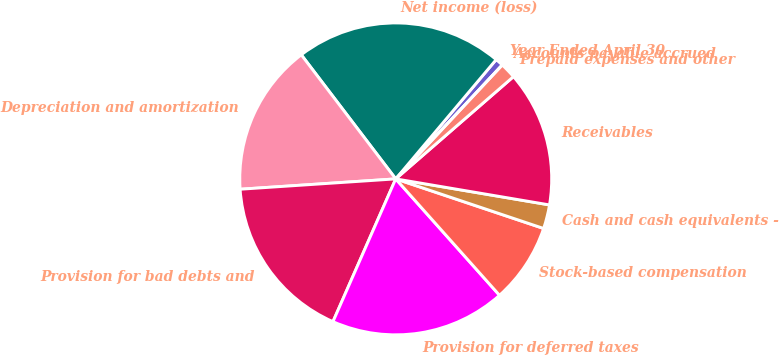Convert chart. <chart><loc_0><loc_0><loc_500><loc_500><pie_chart><fcel>Year Ended April 30<fcel>Net income (loss)<fcel>Depreciation and amortization<fcel>Provision for bad debts and<fcel>Provision for deferred taxes<fcel>Stock-based compensation<fcel>Cash and cash equivalents -<fcel>Receivables<fcel>Prepaid expenses and other<fcel>Accounts payable accrued<nl><fcel>0.83%<fcel>21.49%<fcel>15.7%<fcel>17.35%<fcel>18.18%<fcel>8.26%<fcel>2.48%<fcel>14.05%<fcel>1.65%<fcel>0.0%<nl></chart> 